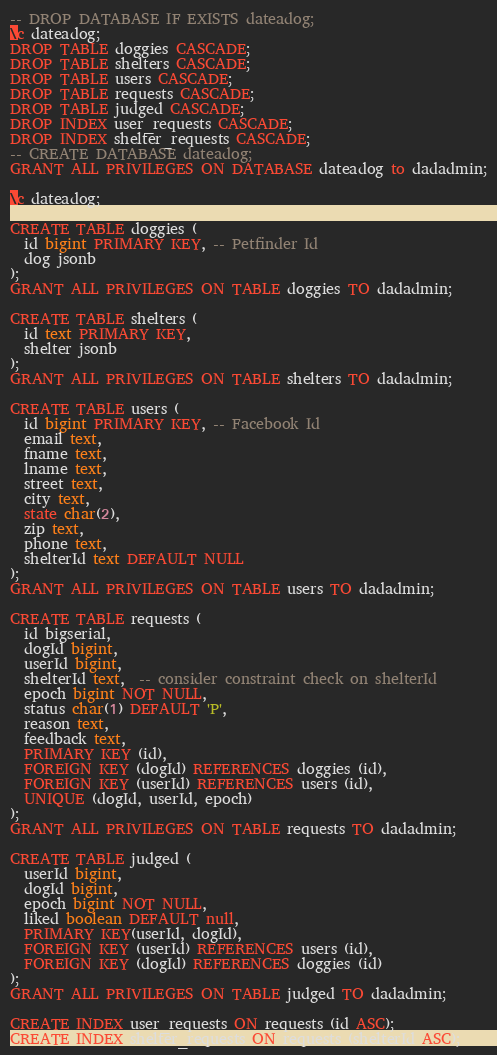<code> <loc_0><loc_0><loc_500><loc_500><_SQL_>-- DROP DATABASE IF EXISTS dateadog;
\c dateadog;
DROP TABLE doggies CASCADE;
DROP TABLE shelters CASCADE;
DROP TABLE users CASCADE;
DROP TABLE requests CASCADE;
DROP TABLE judged CASCADE;
DROP INDEX user_requests CASCADE;
DROP INDEX shelter_requests CASCADE;
-- CREATE DATABASE dateadog;
GRANT ALL PRIVILEGES ON DATABASE dateadog to dadadmin;

\c dateadog;

CREATE TABLE doggies (
  id bigint PRIMARY KEY, -- Petfinder Id
  dog jsonb
);
GRANT ALL PRIVILEGES ON TABLE doggies TO dadadmin;

CREATE TABLE shelters (
  id text PRIMARY KEY,
  shelter jsonb
);
GRANT ALL PRIVILEGES ON TABLE shelters TO dadadmin;

CREATE TABLE users (
  id bigint PRIMARY KEY, -- Facebook Id
  email text,
  fname text,
  lname text,
  street text,
  city text,
  state char(2),
  zip text,
  phone text,
  shelterId text DEFAULT NULL
);
GRANT ALL PRIVILEGES ON TABLE users TO dadadmin;

CREATE TABLE requests (
  id bigserial,
  dogId bigint,
  userId bigint,
  shelterId text,  -- consider constraint check on shelterId
  epoch bigint NOT NULL,
  status char(1) DEFAULT 'P',
  reason text,
  feedback text,
  PRIMARY KEY (id),
  FOREIGN KEY (dogId) REFERENCES doggies (id),
  FOREIGN KEY (userId) REFERENCES users (id),
  UNIQUE (dogId, userId, epoch)
);
GRANT ALL PRIVILEGES ON TABLE requests TO dadadmin;

CREATE TABLE judged (
  userId bigint,
  dogId bigint,
  epoch bigint NOT NULL,
  liked boolean DEFAULT null,
  PRIMARY KEY(userId, dogId),
  FOREIGN KEY (userId) REFERENCES users (id),
  FOREIGN KEY (dogId) REFERENCES doggies (id)
);
GRANT ALL PRIVILEGES ON TABLE judged TO dadadmin;

CREATE INDEX user_requests ON requests (id ASC);
CREATE INDEX shelter_requests ON requests (shelterId ASC);
</code> 